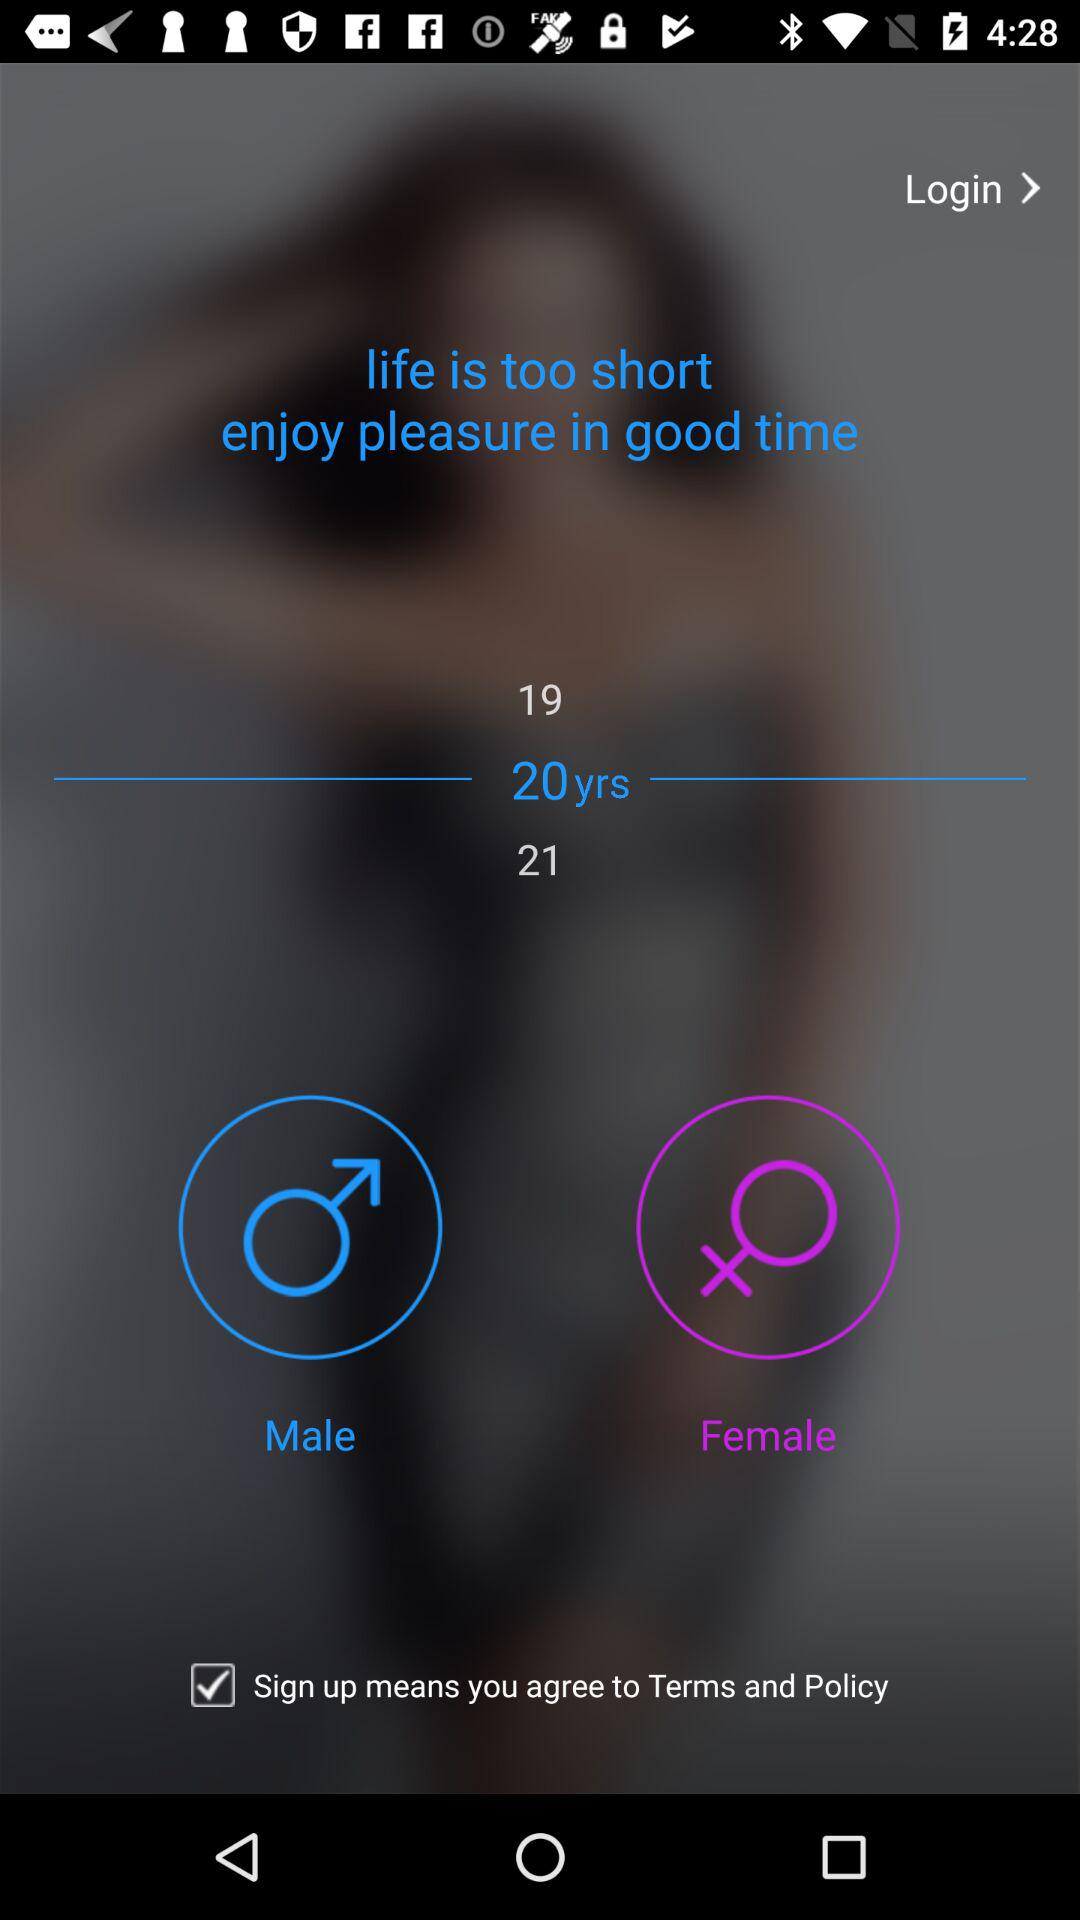How many years are displayed in the age selection?
Answer the question using a single word or phrase. 3 